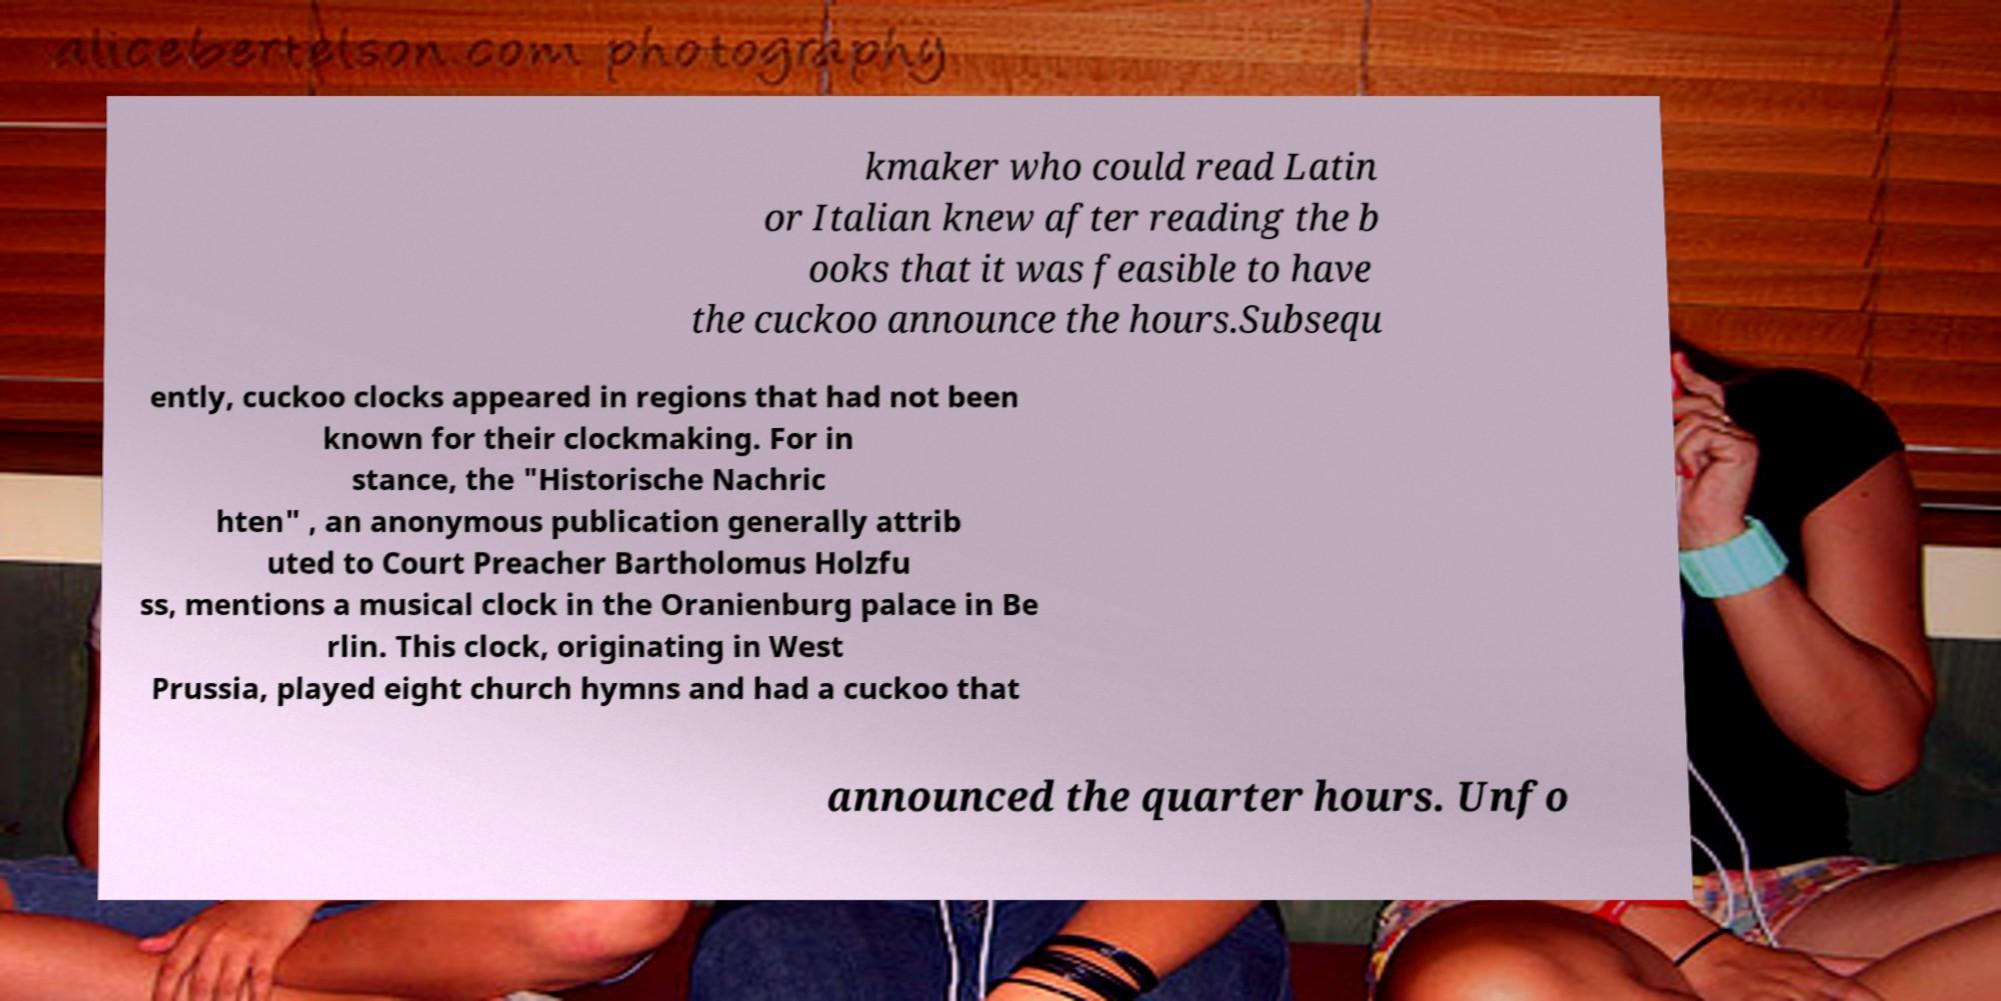There's text embedded in this image that I need extracted. Can you transcribe it verbatim? kmaker who could read Latin or Italian knew after reading the b ooks that it was feasible to have the cuckoo announce the hours.Subsequ ently, cuckoo clocks appeared in regions that had not been known for their clockmaking. For in stance, the "Historische Nachric hten" , an anonymous publication generally attrib uted to Court Preacher Bartholomus Holzfu ss, mentions a musical clock in the Oranienburg palace in Be rlin. This clock, originating in West Prussia, played eight church hymns and had a cuckoo that announced the quarter hours. Unfo 